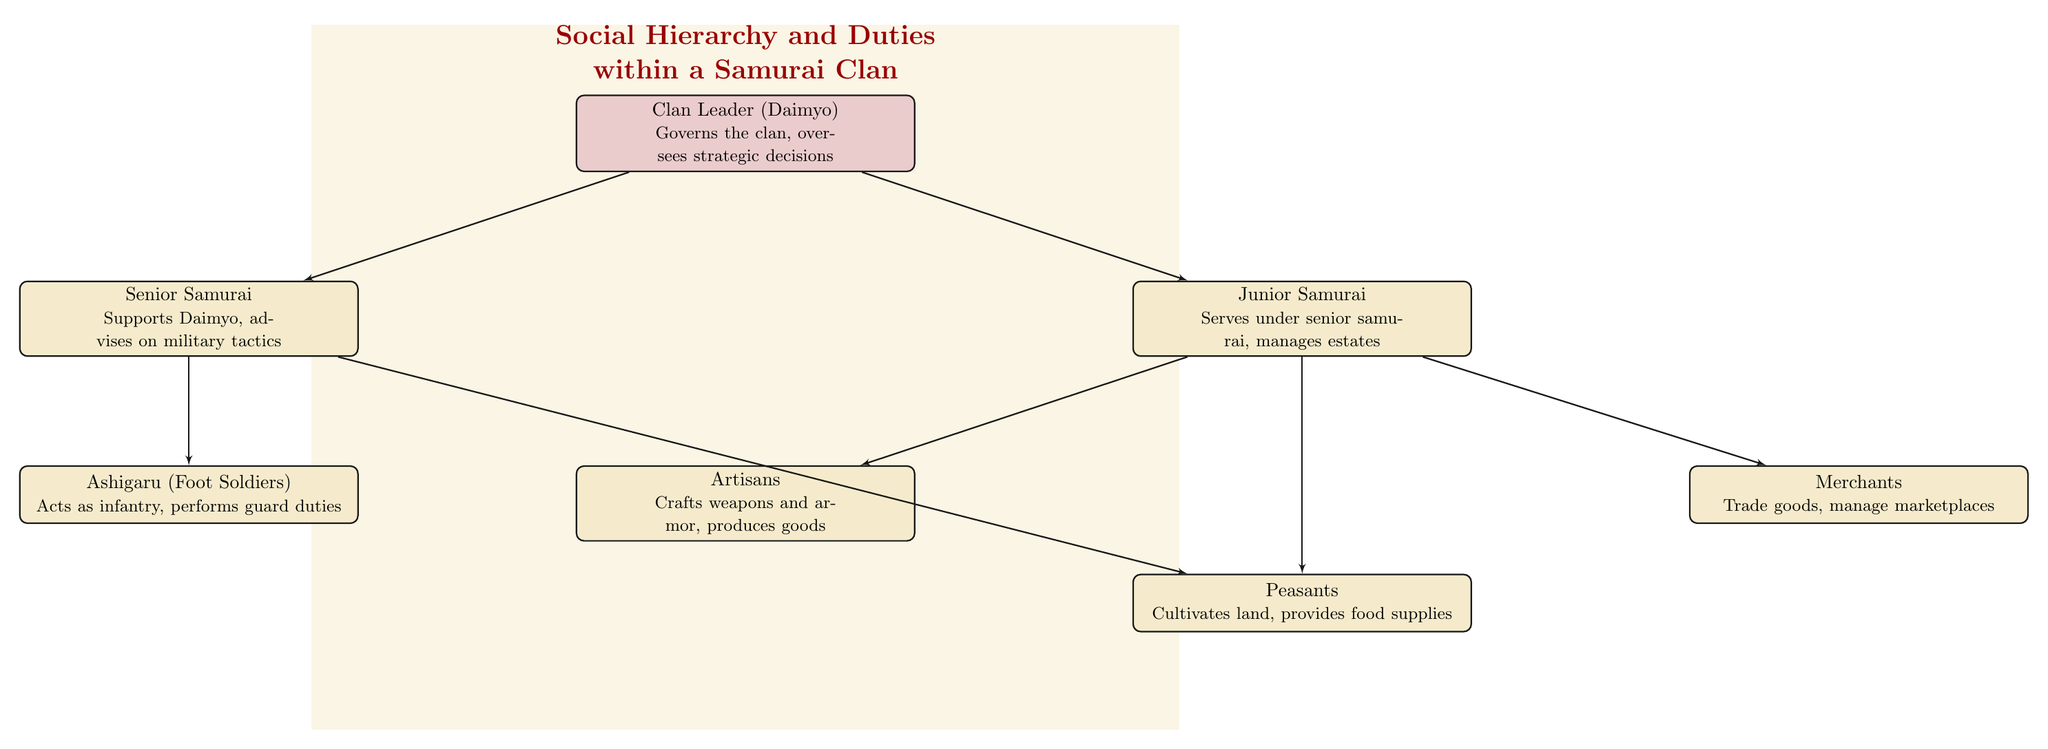What is the top position in the social hierarchy? The diagram indicates that the top position is the Clan Leader (Daimyo), as it is the first node in the hierarchy, signifying the leader's authority over the entire clan.
Answer: Clan Leader (Daimyo) How many types of samurai are mentioned? The diagram shows two types of samurai: Senior Samurai and Junior Samurai. Counting these nodes gives a total of two types.
Answer: 2 Who is responsible for crafting weapons and armor? From the diagram, Artisans are identified as responsible for crafting weapons and armor, which is explicitly mentioned in their duties.
Answer: Artisans Which group directly supports the Daimyo? The diagram indicates that the Senior Samurai directly supports the Daimyo, as they are positioned directly below him and listed as advisors.
Answer: Senior Samurai What roles do the Ashigaru fulfill? According to the diagram, the Ashigaru (Foot Soldiers) act as infantry in battles and perform guard duties. Their responsibilities show that they are primarily military support.
Answer: Acts as infantry, performs guard duties Which two groups manage the peasants? The diagram indicates that both Senior Samurai and Junior Samurai manage the Peasants, as lines connect these nodes to the Peasants node.
Answer: Senior Samurai, Junior Samurai What is the relationship between Junior Samurai and Merchants? The diagram illustrates that Junior Samurai manage Merchants; the Junior Samurai node connects directly to the Merchants node, indicating oversight.
Answer: Junior Samurai Who is tasked with providing food supplies? The diagram specifies that Peasants are responsible for cultivating land and providing food supplies, showcasing their vital role in the clan's sustenance.
Answer: Peasants How many levels are there in the hierarchy? The diagram visually shows three levels within the hierarchy, starting from the Daimyo at the top and moving down through Samurai to Peasants as the base.
Answer: 3 